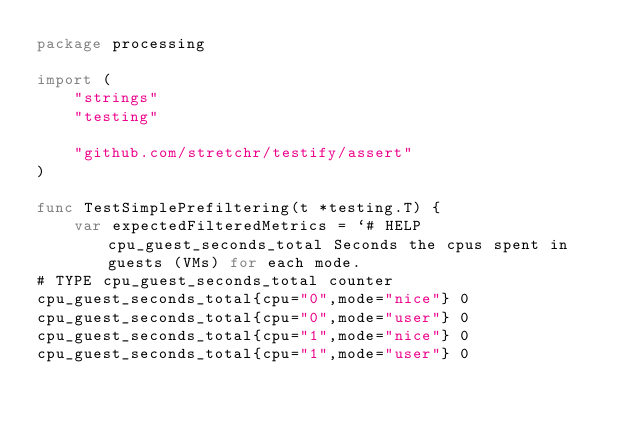<code> <loc_0><loc_0><loc_500><loc_500><_Go_>package processing

import (
	"strings"
	"testing"

	"github.com/stretchr/testify/assert"
)

func TestSimplePrefiltering(t *testing.T) {
	var expectedFilteredMetrics = `# HELP cpu_guest_seconds_total Seconds the cpus spent in guests (VMs) for each mode.
# TYPE cpu_guest_seconds_total counter
cpu_guest_seconds_total{cpu="0",mode="nice"} 0
cpu_guest_seconds_total{cpu="0",mode="user"} 0
cpu_guest_seconds_total{cpu="1",mode="nice"} 0
cpu_guest_seconds_total{cpu="1",mode="user"} 0</code> 